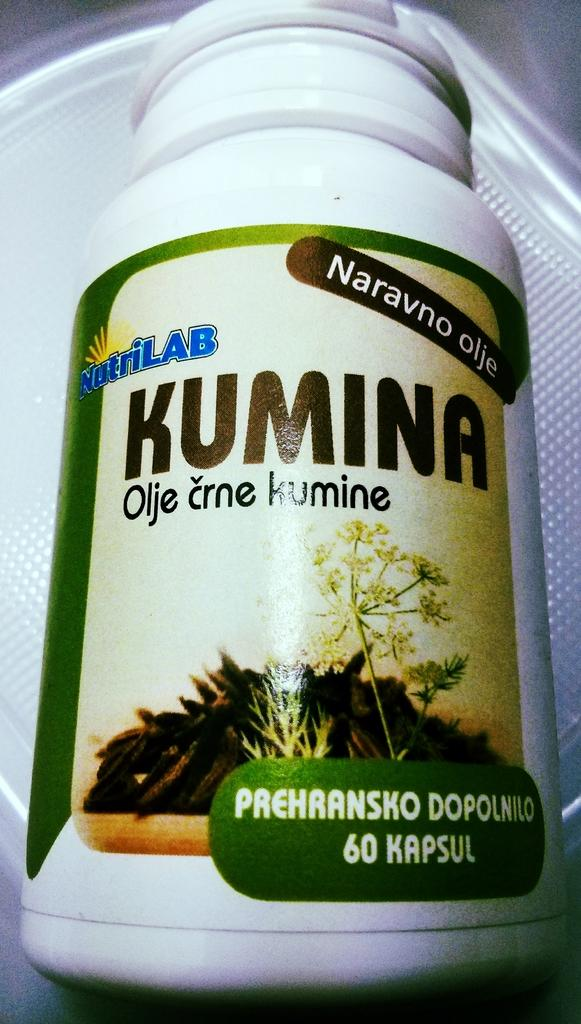What is the color of the bottle in the image? The bottle in the image is white. What can be found on the bottle? The bottle has text on it. What is the color of the surface in the image? The surface in the image is white. Can you see any bubbles coming out of the bottle in the image? There are no bubbles visible in the image; it only shows a white color bottle with text on it. 